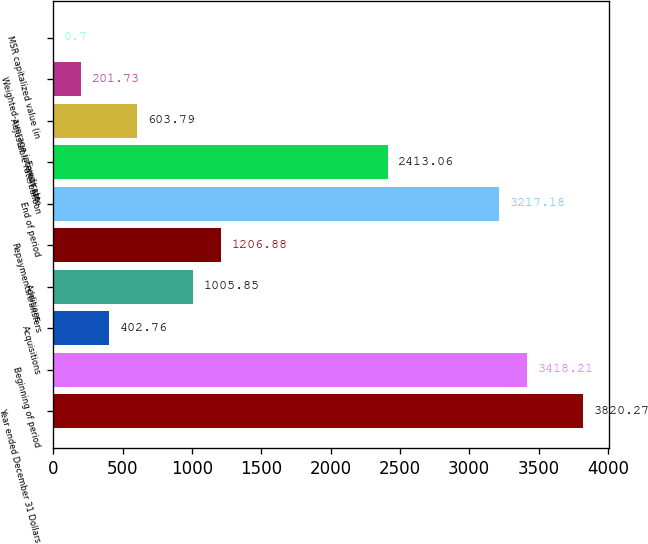Convert chart to OTSL. <chart><loc_0><loc_0><loc_500><loc_500><bar_chart><fcel>Year ended December 31 Dollars<fcel>Beginning of period<fcel>Acquisitions<fcel>Additions<fcel>Repayments/transfers<fcel>End of period<fcel>Fixed rate<fcel>Adjustable rate/balloon<fcel>Weighted-average interest rate<fcel>MSR capitalized value (in<nl><fcel>3820.27<fcel>3418.21<fcel>402.76<fcel>1005.85<fcel>1206.88<fcel>3217.18<fcel>2413.06<fcel>603.79<fcel>201.73<fcel>0.7<nl></chart> 